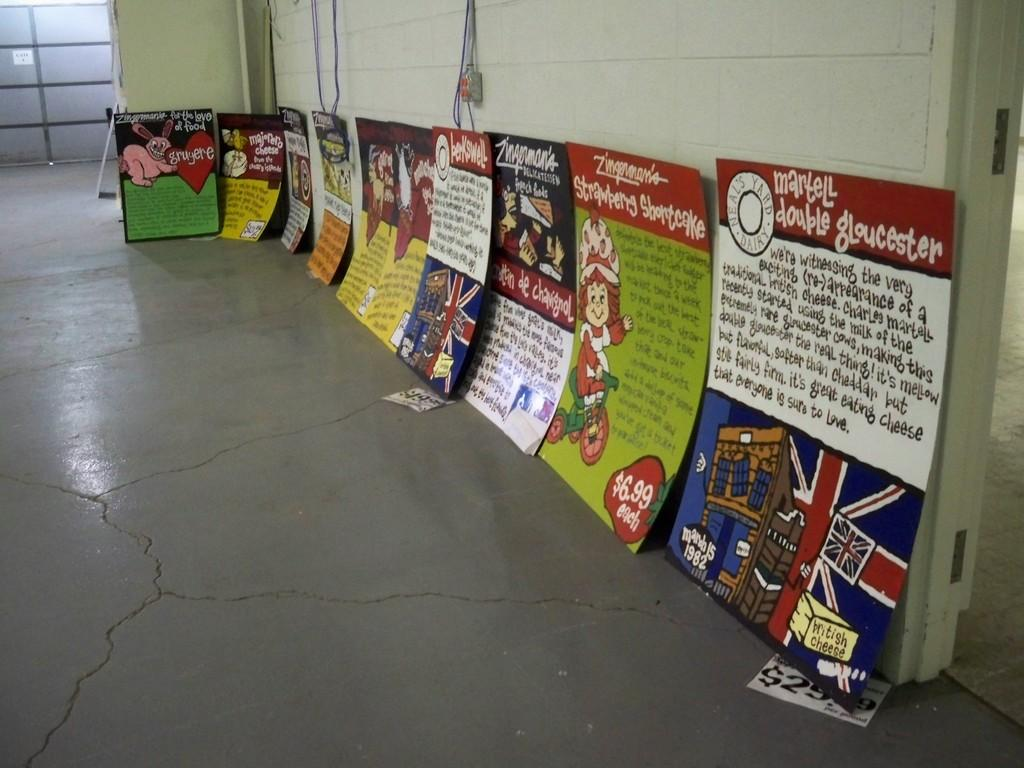Provide a one-sentence caption for the provided image. A hallway of signs where the closest one says Martell double gloucester. 